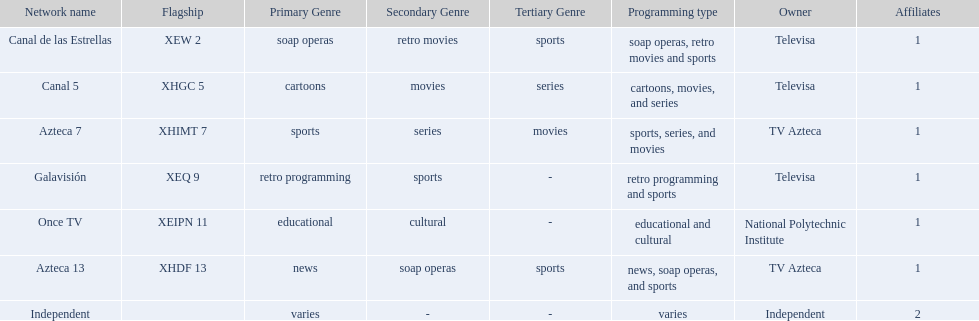Who are the owners of the stations listed here? Televisa, Televisa, TV Azteca, Televisa, National Polytechnic Institute, TV Azteca, Independent. What is the one station owned by national polytechnic institute? Once TV. 